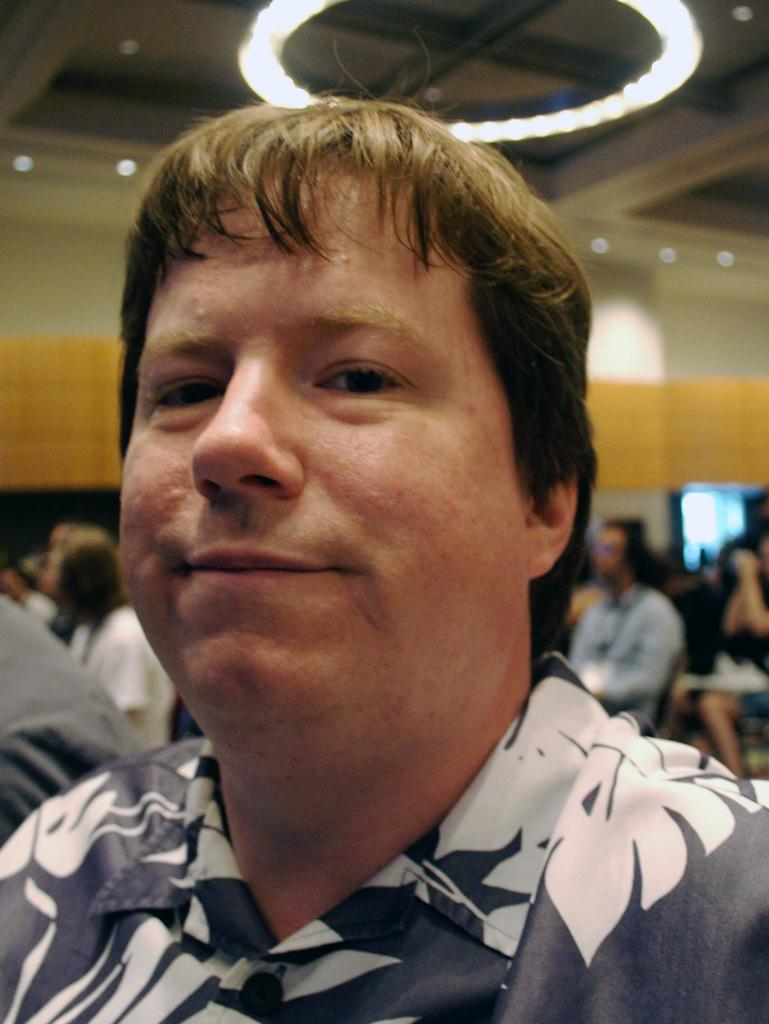What is the main subject of the image? There is a person in the image. What can be observed about the person's attire? The person is wearing clothes. Can you describe the background of the image? The background of the image is blurred. What type of banana is being discussed by the committee in the image? There is no banana or committee present in the image. What kind of trouble is the person in the image facing? There is no indication of trouble in the image; it only shows a person wearing clothes with a blurred background. 